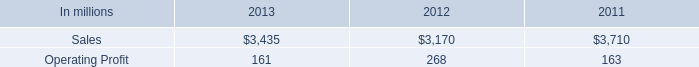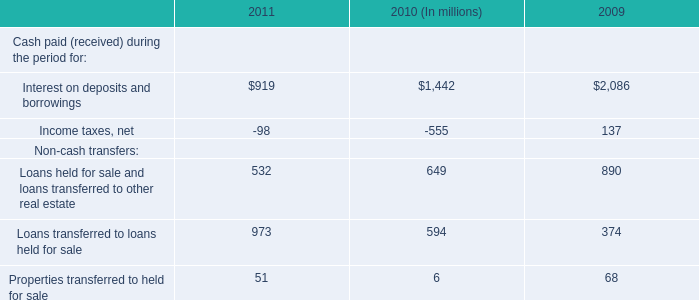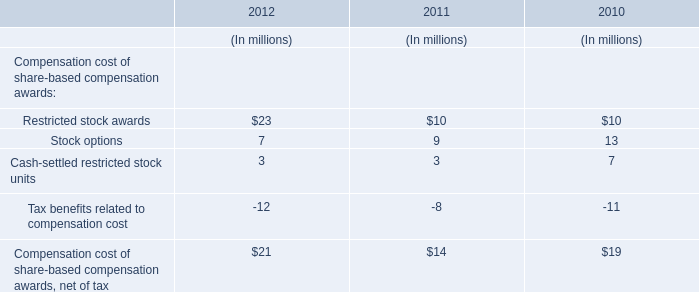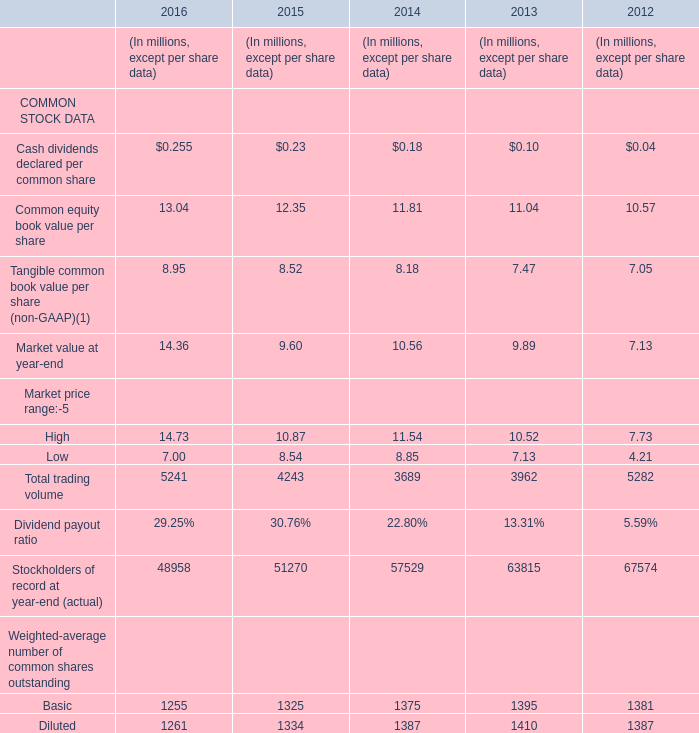in 2013 what percentage of consumer packaging sales is attributable to north american consumer packaging net sales? 
Computations: ((2 * 1000) / 3435)
Answer: 0.58224. 